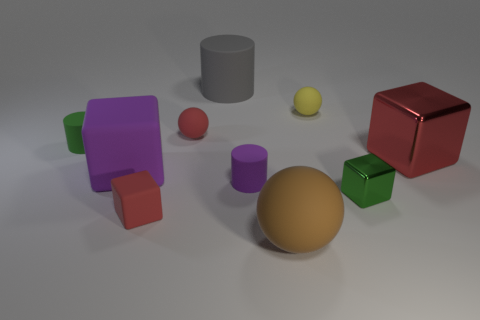What number of things are either brown rubber things or big matte objects that are on the right side of the gray matte cylinder?
Give a very brief answer. 1. How big is the red block on the right side of the large matte ball?
Provide a succinct answer. Large. Is the number of small purple matte cylinders behind the large gray matte object less than the number of matte cylinders to the right of the green matte thing?
Make the answer very short. Yes. What is the material of the ball that is both behind the small green block and in front of the tiny yellow ball?
Offer a terse response. Rubber. What shape is the thing behind the small rubber ball on the right side of the gray rubber object?
Your response must be concise. Cylinder. Is the color of the large metal object the same as the small rubber cube?
Ensure brevity in your answer.  Yes. How many blue things are large metallic objects or small rubber cylinders?
Provide a succinct answer. 0. Are there any tiny red things behind the tiny green rubber object?
Ensure brevity in your answer.  Yes. What size is the yellow matte ball?
Your answer should be very brief. Small. What is the size of the purple rubber thing that is the same shape as the big gray object?
Your answer should be very brief. Small. 